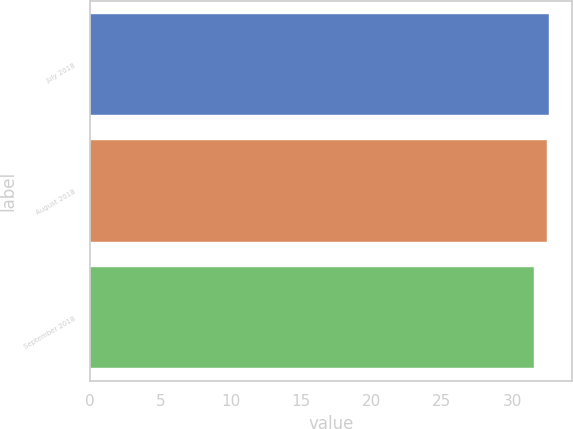<chart> <loc_0><loc_0><loc_500><loc_500><bar_chart><fcel>July 2018<fcel>August 2018<fcel>September 2018<nl><fcel>32.59<fcel>32.44<fcel>31.53<nl></chart> 